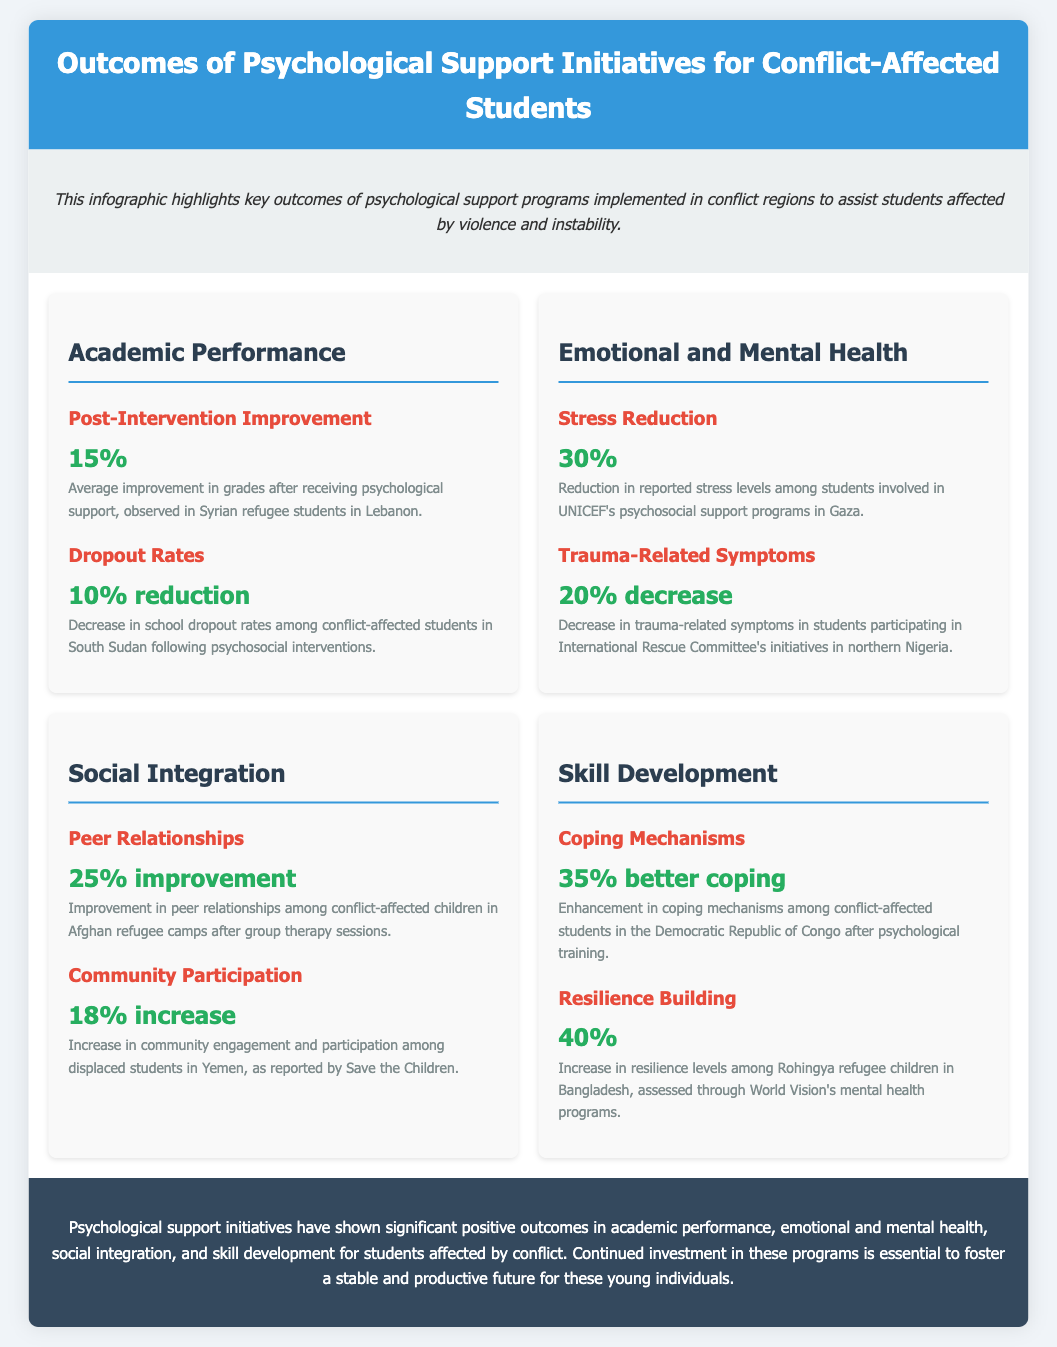What is the average improvement in grades after psychological support? The average improvement in grades is reported as 15% for Syrian refugee students in Lebanon.
Answer: 15% What percentage of reduction in school dropout rates was observed? The document states there was a 10% reduction in school dropout rates among conflict-affected students in South Sudan.
Answer: 10% reduction What is the decrease in reported stress levels in Gaza? According to the infographic, there is a 30% reduction in reported stress levels among students in UNICEF's psychosocial support programs in Gaza.
Answer: 30% What percentage increase is noted in community participation among displaced students in Yemen? The infographic highlights an 18% increase in community participation among displaced students in Yemen, reported by Save the Children.
Answer: 18% increase What is the improvement in peer relationships among conflict-affected children in Afghan refugee camps? The improvement in peer relationships among these children is reported as 25% after group therapy sessions.
Answer: 25% improvement What percentage of better coping mechanisms was reported after psychological training in the Democratic Republic of Congo? The document states there was a 35% enhancement in coping mechanisms after psychological training.
Answer: 35% better coping What is the increase in resilience levels among Rohingya refugee children in Bangladesh? The increase in resilience levels reported is 40%, as assessed through World Vision's mental health programs.
Answer: 40% What are the key areas of impact highlighted in the infographic? The infographic highlights academic performance, emotional and mental health, social integration, and skill development as key areas.
Answer: Academic performance, emotional and mental health, social integration, and skill development 